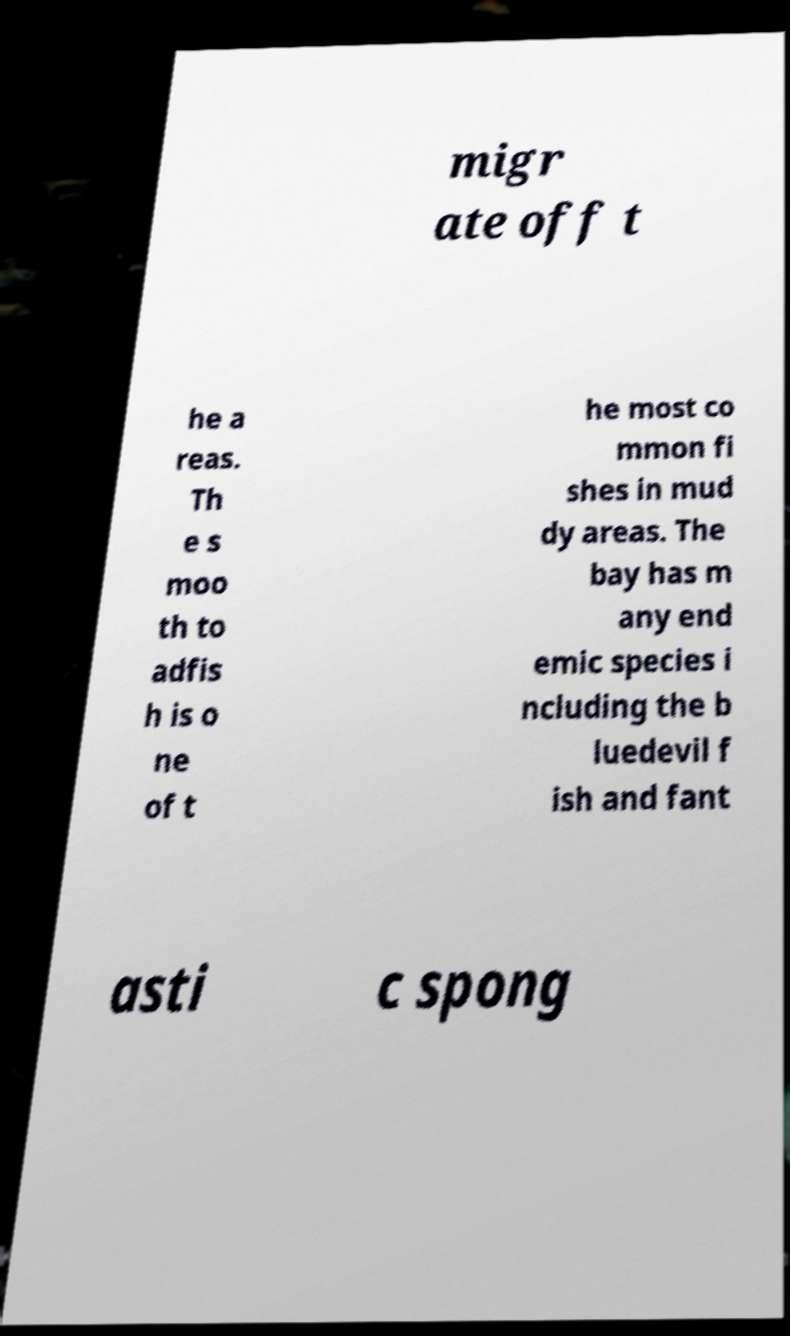What messages or text are displayed in this image? I need them in a readable, typed format. migr ate off t he a reas. Th e s moo th to adfis h is o ne of t he most co mmon fi shes in mud dy areas. The bay has m any end emic species i ncluding the b luedevil f ish and fant asti c spong 